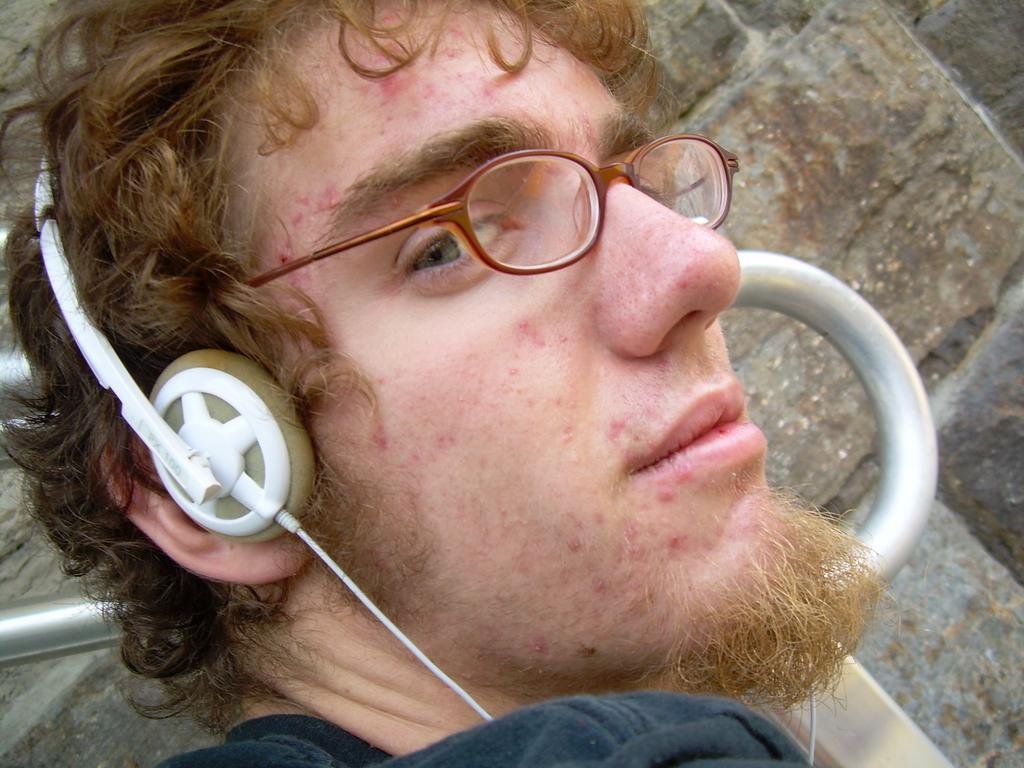What is the main subject in the foreground of the image? There is a person in the foreground of the image. What is the person wearing on their head? The person is wearing a headset. What type of eyewear is the person wearing? The person is wearing spectacles. What can be seen in the background of the image? There is a wall in the background of the image. What type of bag is the person's father carrying in the image? There is no bag or father present in the image; it only features a person wearing a headset and spectacles with a wall in the background. 